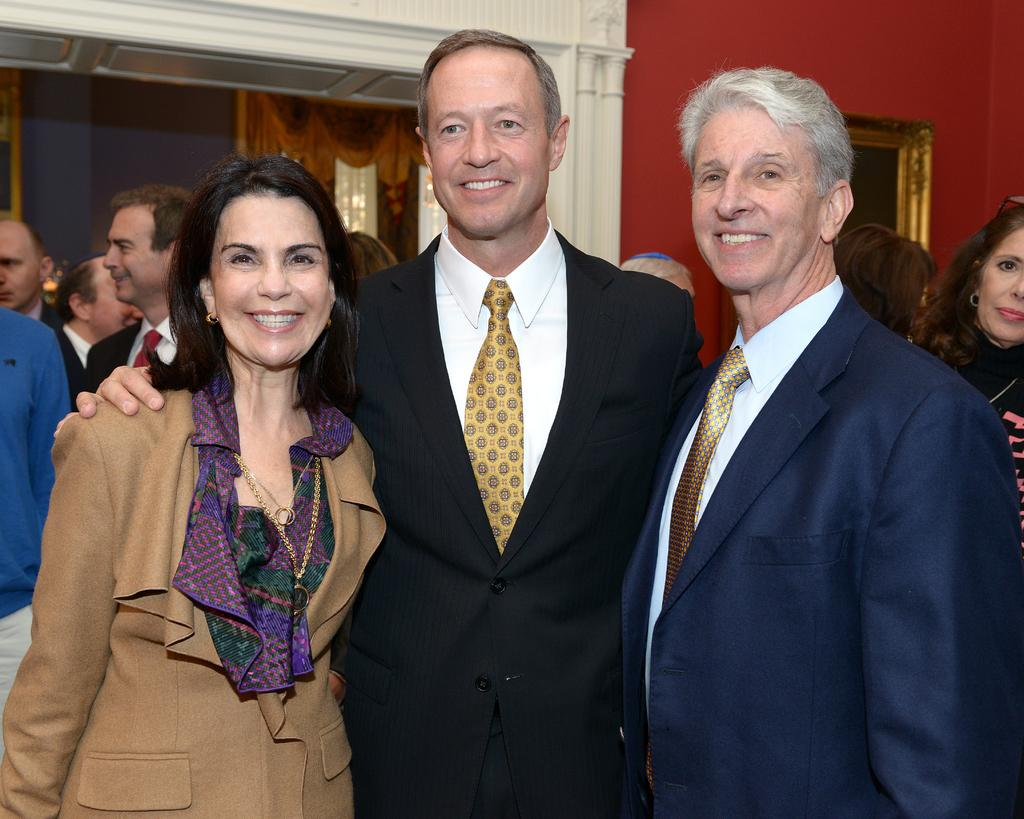How many men are in the image? There are two men standing in the image. What are the men wearing? The men are wearing suits. Who is standing beside one of the men? There is a woman standing beside one of the men. What can be seen in the background of the image? In the background of the image, there are people standing and a wall is visible. What type of nut can be seen floating in the river in the image? There is no river or nut present in the image. What color is the lipstick worn by the woman in the image? There is no lipstick or woman wearing lipstick present in the image. 